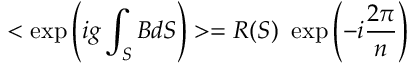Convert formula to latex. <formula><loc_0><loc_0><loc_500><loc_500>< \exp \left ( i g \int _ { S } B d S \right ) > = R ( S ) \exp \left ( - i \frac { 2 \pi } { n } \right )</formula> 